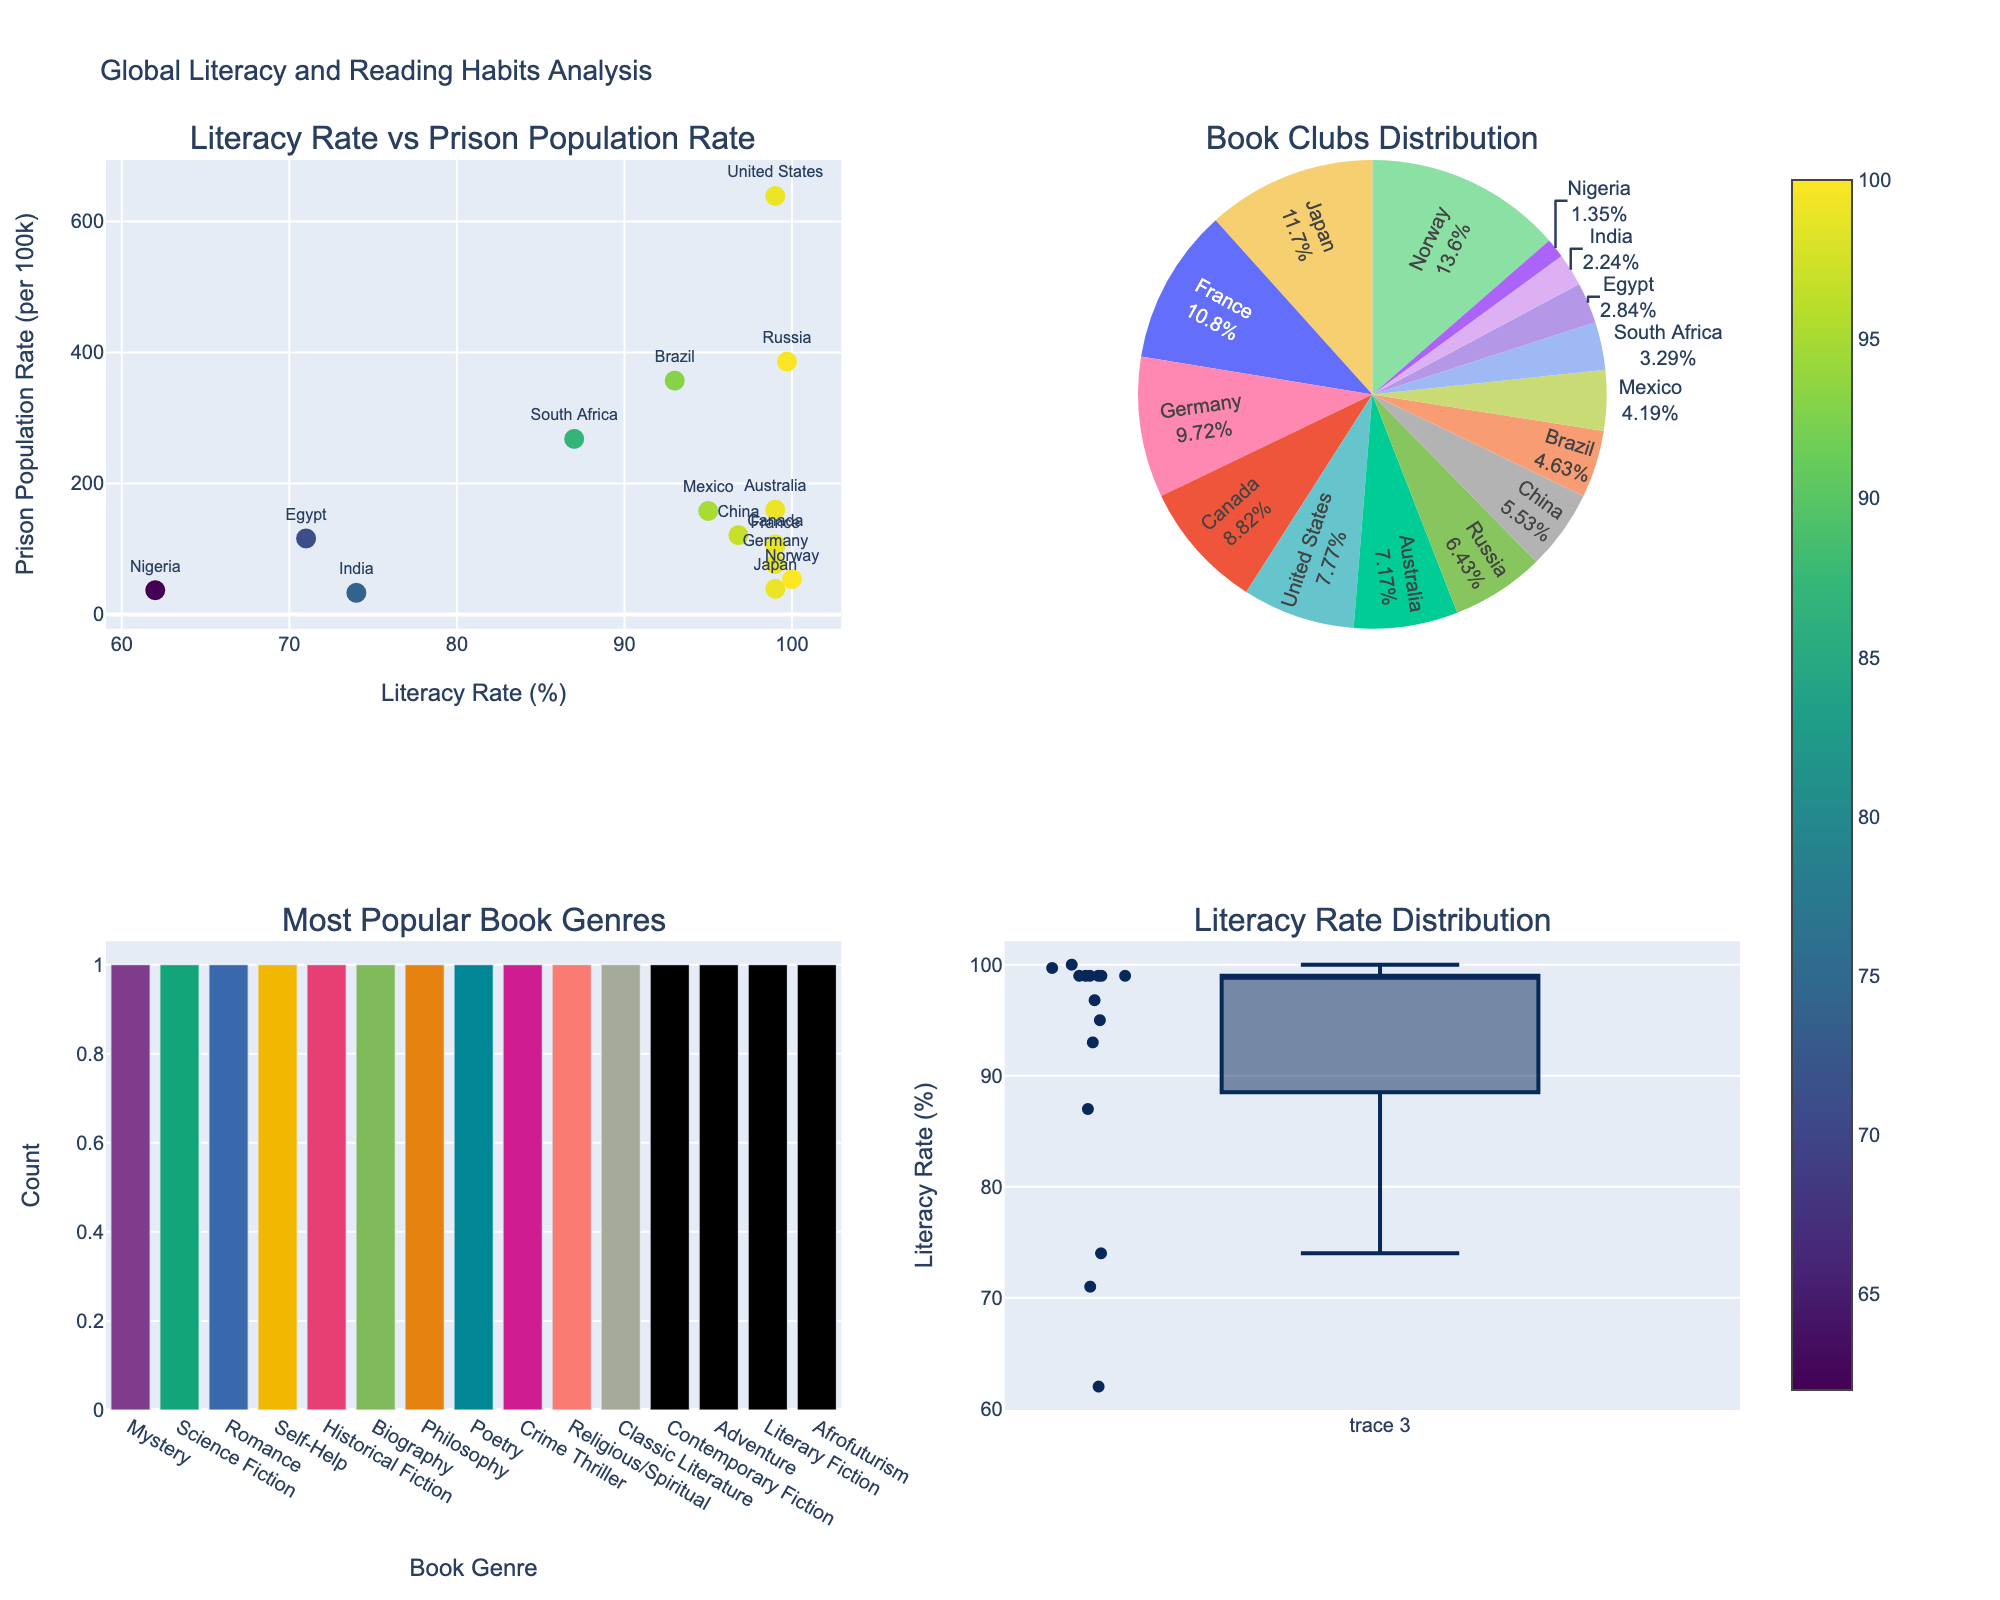How many countries have a literacy rate above 95%? Observing the scatter plot and the box plot, the countries with literacy rates above 95% are the United States, Japan, Russia, Germany, Norway, China, Canada, and France.
Answer: 8 Which country has the highest prison population rate? In the scatter plot, the country with the maximum y-value is the United States.
Answer: United States Which genre is the most popular among the countries? Looking at the bar chart, the height of the bar representing the most popular genre is "Science Fiction".
Answer: Science Fiction What is the average literacy rate of the countries displayed? Summing the literacy rates: 99+99+93+74+99.7+87+99+95+100+71+96.8+99+99+99+62 and dividing by 15 gives 92.48%.
Answer: 92.48% Which country has the highest number of book clubs per million people? From the pie chart, the largest slice represents Norway.
Answer: Norway How is the literacy rate distributed among the countries? Examining the box plot, the median literacy rate seems to be around 95%, with some outliers above and below this value.
Answer: Median around 95% Which countries have a prison population rate less than 50 per 100k people? According to the scatter plot, the countries with a prison population rate below 50 per 100k are Japan (39) and India (33).
Answer: Japan, India Are there more countries with a literacy rate of 99% or with less than 99%? Observing the scatter plot and dataset, the countries with 99% literacy are: United States, Japan, Germany, Canada, Australia, France, making it 6. Countries with less than 99% are: Brazil, India, South Africa, Mexico, Egypt, China, Nigeria, making it 8.
Answer: Less than 99% Which country has the lowest literacy rate, and what is its most popular book genre? From the scatter plot, the country with the lowest plot point is Nigeria, with a literacy rate of 62%. The genre from the data is Afrofuturism.
Answer: Nigeria, Afrofuturism 